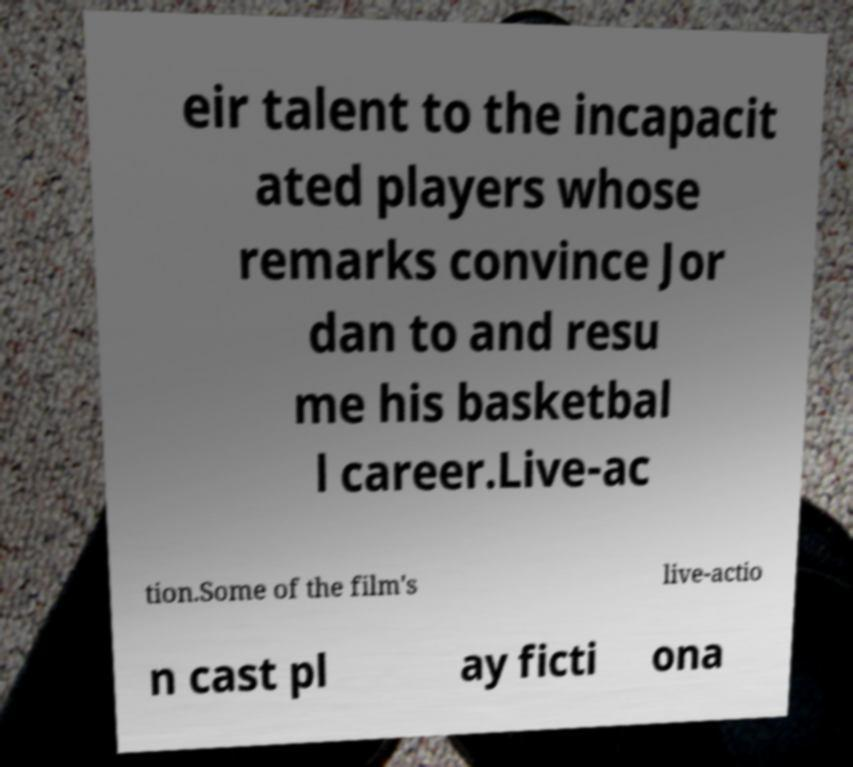Please identify and transcribe the text found in this image. eir talent to the incapacit ated players whose remarks convince Jor dan to and resu me his basketbal l career.Live-ac tion.Some of the film's live-actio n cast pl ay ficti ona 